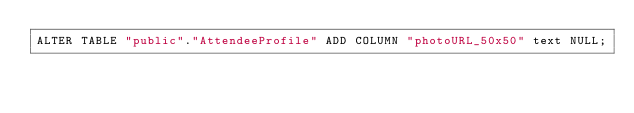<code> <loc_0><loc_0><loc_500><loc_500><_SQL_>ALTER TABLE "public"."AttendeeProfile" ADD COLUMN "photoURL_50x50" text NULL;
</code> 